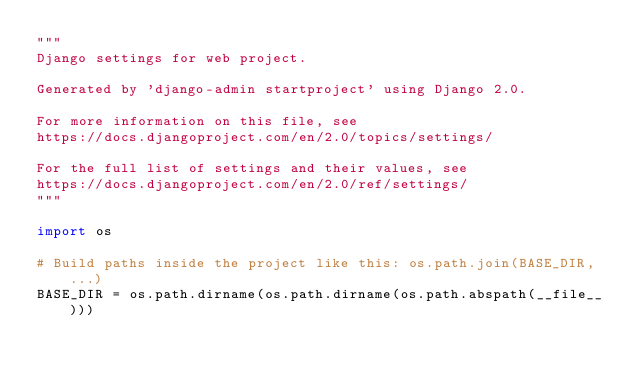<code> <loc_0><loc_0><loc_500><loc_500><_Python_>"""
Django settings for web project.

Generated by 'django-admin startproject' using Django 2.0.

For more information on this file, see
https://docs.djangoproject.com/en/2.0/topics/settings/

For the full list of settings and their values, see
https://docs.djangoproject.com/en/2.0/ref/settings/
"""

import os

# Build paths inside the project like this: os.path.join(BASE_DIR, ...)
BASE_DIR = os.path.dirname(os.path.dirname(os.path.abspath(__file__)))

</code> 